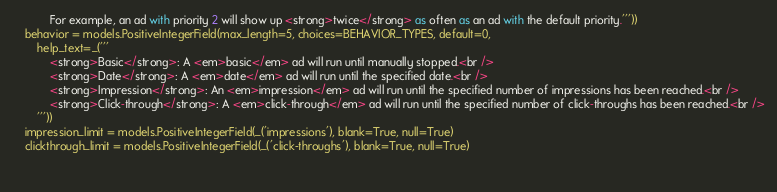Convert code to text. <code><loc_0><loc_0><loc_500><loc_500><_Python_>            For example, an ad with priority 2 will show up <strong>twice</strong> as often as an ad with the default priority.'''))
    behavior = models.PositiveIntegerField(max_length=5, choices=BEHAVIOR_TYPES, default=0,
        help_text=_('''
            <strong>Basic</strong>: A <em>basic</em> ad will run until manually stopped.<br />
            <strong>Date</strong>: A <em>date</em> ad will run until the specified date.<br />
            <strong>Impression</strong>: An <em>impression</em> ad will run until the specified number of impressions has been reached.<br />
            <strong>Click-through</strong>: A <em>click-through</em> ad will run until the specified number of click-throughs has been reached.<br />
        '''))
    impression_limit = models.PositiveIntegerField(_('impressions'), blank=True, null=True)
    clickthrough_limit = models.PositiveIntegerField(_('click-throughs'), blank=True, null=True)
    
    </code> 